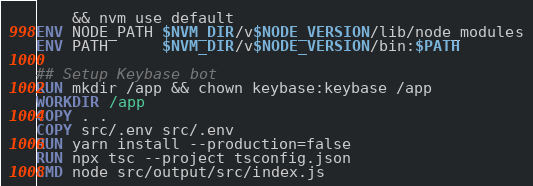Convert code to text. <code><loc_0><loc_0><loc_500><loc_500><_Dockerfile_>    && nvm use default
ENV NODE_PATH $NVM_DIR/v$NODE_VERSION/lib/node_modules
ENV PATH      $NVM_DIR/v$NODE_VERSION/bin:$PATH

## Setup Keybase bot
RUN mkdir /app && chown keybase:keybase /app
WORKDIR /app
COPY . .
COPY src/.env src/.env
RUN yarn install --production=false
RUN npx tsc --project tsconfig.json
CMD node src/output/src/index.js</code> 